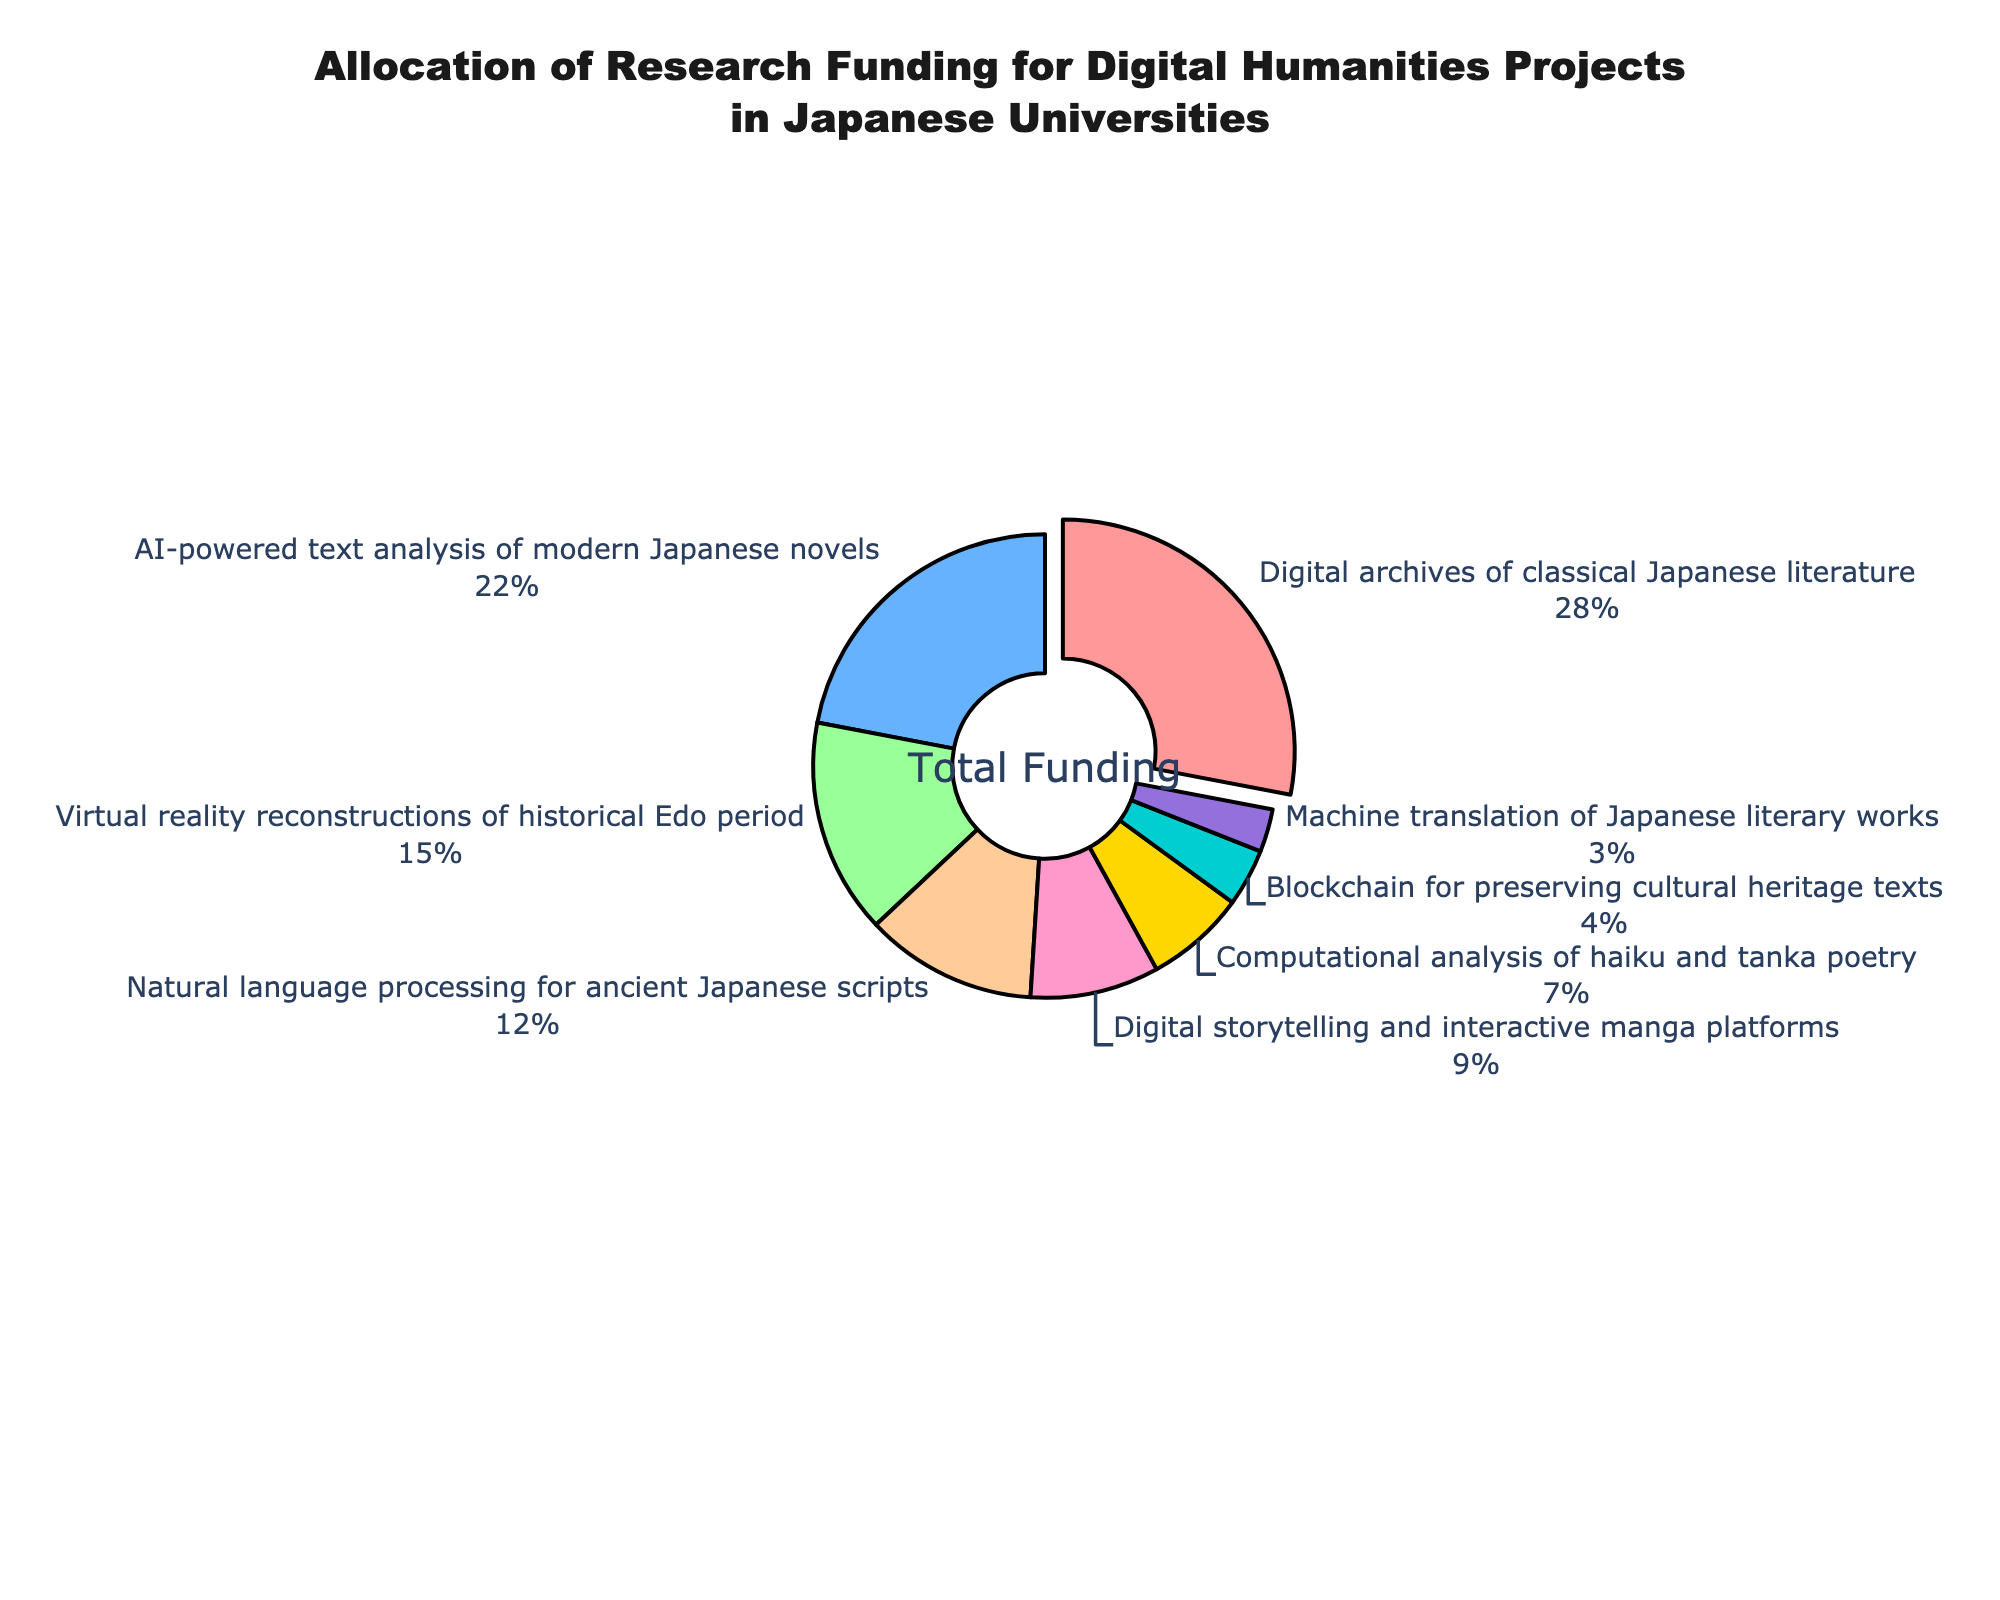What's the total percent allocation for project types involving ancient or classic Japanese literature? Add the percent allocations for "Digital archives of classical Japanese literature" and "Natural language processing for ancient Japanese scripts" (28% + 12%)
Answer: 40% Which project type received the second-highest funding allocation? The project type "AI-powered text analysis of modern Japanese novels" received 22%, the second-highest allocation after "Digital archives of classical Japanese literature"
Answer: AI-powered text analysis of modern Japanese novels How much more funding does "Digital archives of classical Japanese literature" receive compared to "Virtual reality reconstructions of historical Edo period"? Subtract the percent allocation of "Virtual reality reconstructions of historical Edo period" from "Digital archives of classical Japanese literature" (28% - 15%)
Answer: 13% What's the combined percent allocation for projects using AI technologies (AI-powered text analysis, natural language processing, machine translation)? Add the percent allocations for "AI-powered text analysis of modern Japanese novels", "Natural language processing for ancient Japanese scripts", and "Machine translation of Japanese literary works" (22% + 12% + 3%)
Answer: 37% Which project type has the least funding allocation? The project type "Machine translation of Japanese literary works" received only 3%, the least among all the project types
Answer: Machine translation of Japanese literary works Are there more resources allocated to blockchain-based projects or computational analysis of poetry? Compare the percent allocations of "Blockchain for preserving cultural heritage texts" (4%) and "Computational analysis of haiku and tanka poetry" (7%)
Answer: Computational analysis of haiku and tanka poetry By visual comparison, which project type received around a quarter of the total funding? By looking at the sizes of the pie chart slices, "Digital archives of classical Japanese literature" received 28%, which is close to a quarter (25%) of the total funding
Answer: Digital archives of classical Japanese literature Which project types received more than 10% of the total funding? The project types "Digital archives of classical Japanese literature" (28%), "AI-powered text analysis of modern Japanese novels" (22%), and "Virtual reality reconstructions of historical Edo period" (15%), and "Natural language processing for ancient Japanese scripts" (12%) all received more than 10% of the total funding
Answer: Digital archives of classical Japanese literature, AI-powered text analysis of modern Japanese novels, Virtual reality reconstructions of historical Edo period, Natural language processing for ancient Japanese scripts 